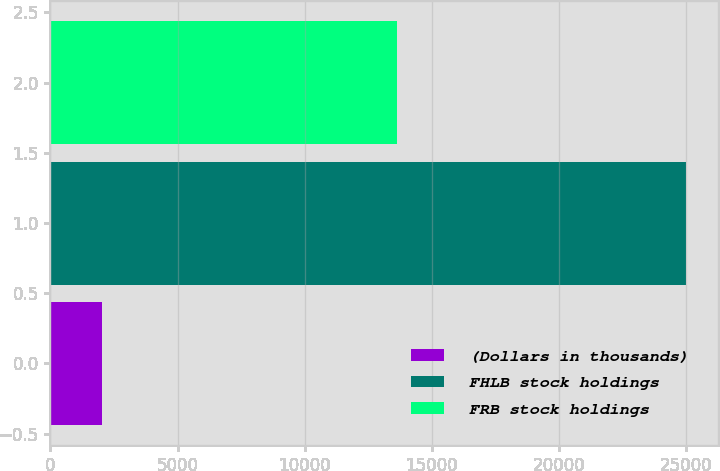<chart> <loc_0><loc_0><loc_500><loc_500><bar_chart><fcel>(Dollars in thousands)<fcel>FHLB stock holdings<fcel>FRB stock holdings<nl><fcel>2010<fcel>25000<fcel>13618<nl></chart> 